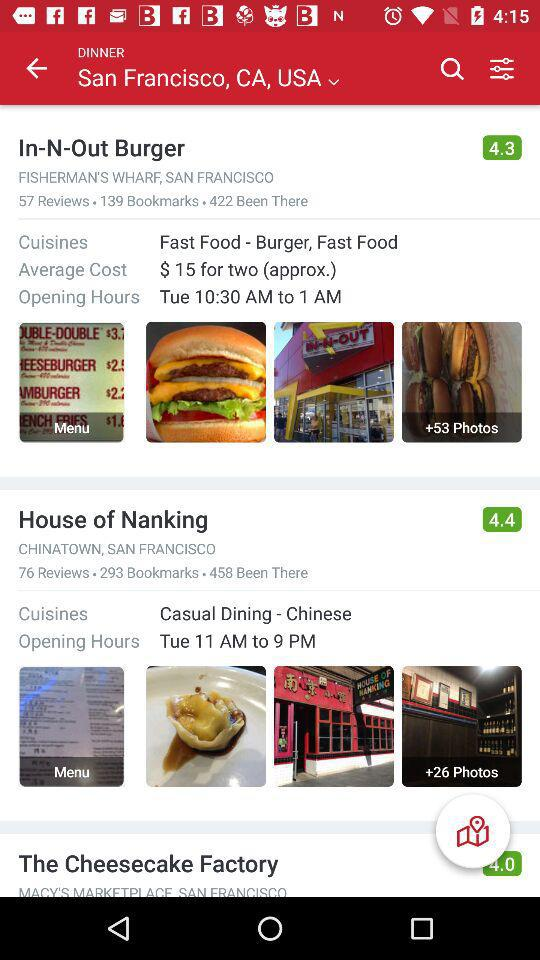What is the rating for "House of Nanking"? The rating is 4.4. 